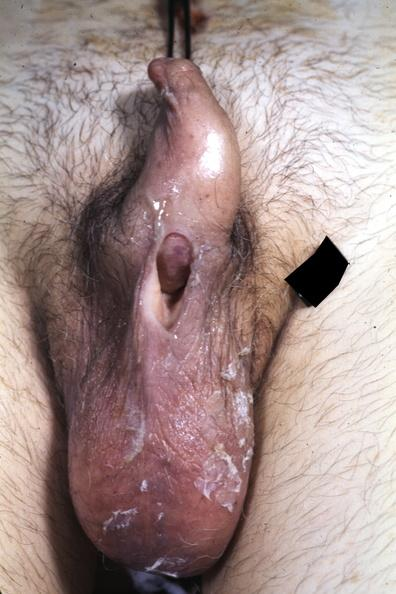s penis present?
Answer the question using a single word or phrase. Yes 